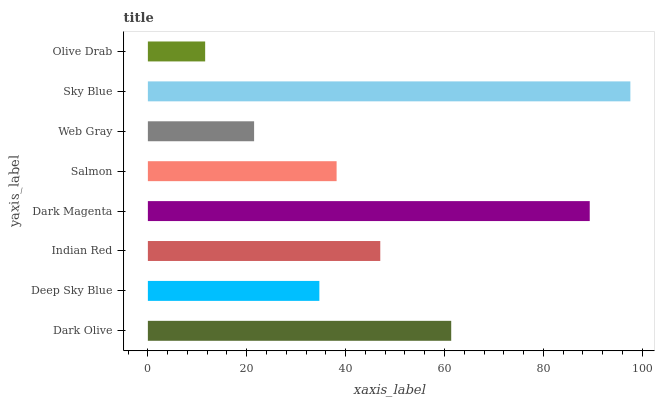Is Olive Drab the minimum?
Answer yes or no. Yes. Is Sky Blue the maximum?
Answer yes or no. Yes. Is Deep Sky Blue the minimum?
Answer yes or no. No. Is Deep Sky Blue the maximum?
Answer yes or no. No. Is Dark Olive greater than Deep Sky Blue?
Answer yes or no. Yes. Is Deep Sky Blue less than Dark Olive?
Answer yes or no. Yes. Is Deep Sky Blue greater than Dark Olive?
Answer yes or no. No. Is Dark Olive less than Deep Sky Blue?
Answer yes or no. No. Is Indian Red the high median?
Answer yes or no. Yes. Is Salmon the low median?
Answer yes or no. Yes. Is Dark Magenta the high median?
Answer yes or no. No. Is Dark Magenta the low median?
Answer yes or no. No. 